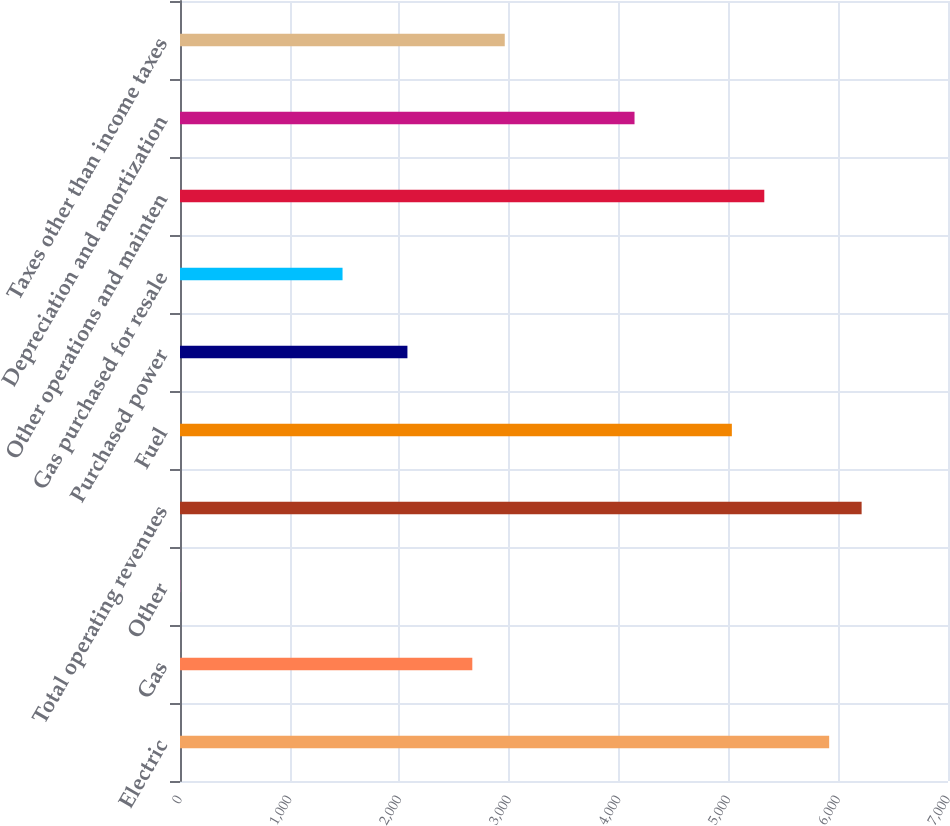<chart> <loc_0><loc_0><loc_500><loc_500><bar_chart><fcel>Electric<fcel>Gas<fcel>Other<fcel>Total operating revenues<fcel>Fuel<fcel>Purchased power<fcel>Gas purchased for resale<fcel>Other operations and mainten<fcel>Depreciation and amortization<fcel>Taxes other than income taxes<nl><fcel>5917<fcel>2664.3<fcel>3<fcel>6212.7<fcel>5029.9<fcel>2072.9<fcel>1481.5<fcel>5325.6<fcel>4142.8<fcel>2960<nl></chart> 